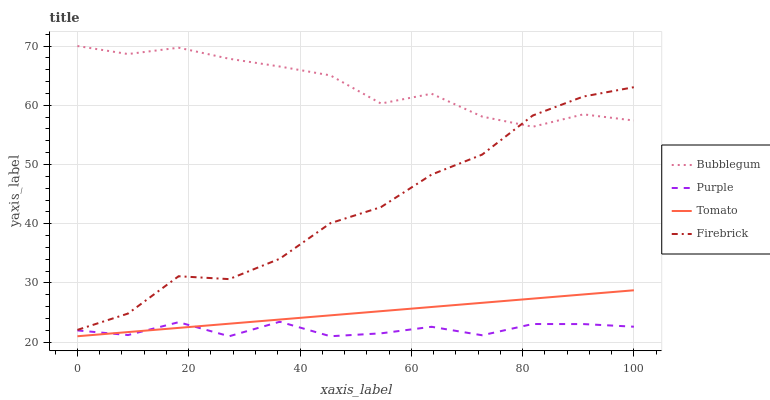Does Tomato have the minimum area under the curve?
Answer yes or no. No. Does Tomato have the maximum area under the curve?
Answer yes or no. No. Is Firebrick the smoothest?
Answer yes or no. No. Is Tomato the roughest?
Answer yes or no. No. Does Firebrick have the lowest value?
Answer yes or no. No. Does Tomato have the highest value?
Answer yes or no. No. Is Purple less than Bubblegum?
Answer yes or no. Yes. Is Bubblegum greater than Purple?
Answer yes or no. Yes. Does Purple intersect Bubblegum?
Answer yes or no. No. 